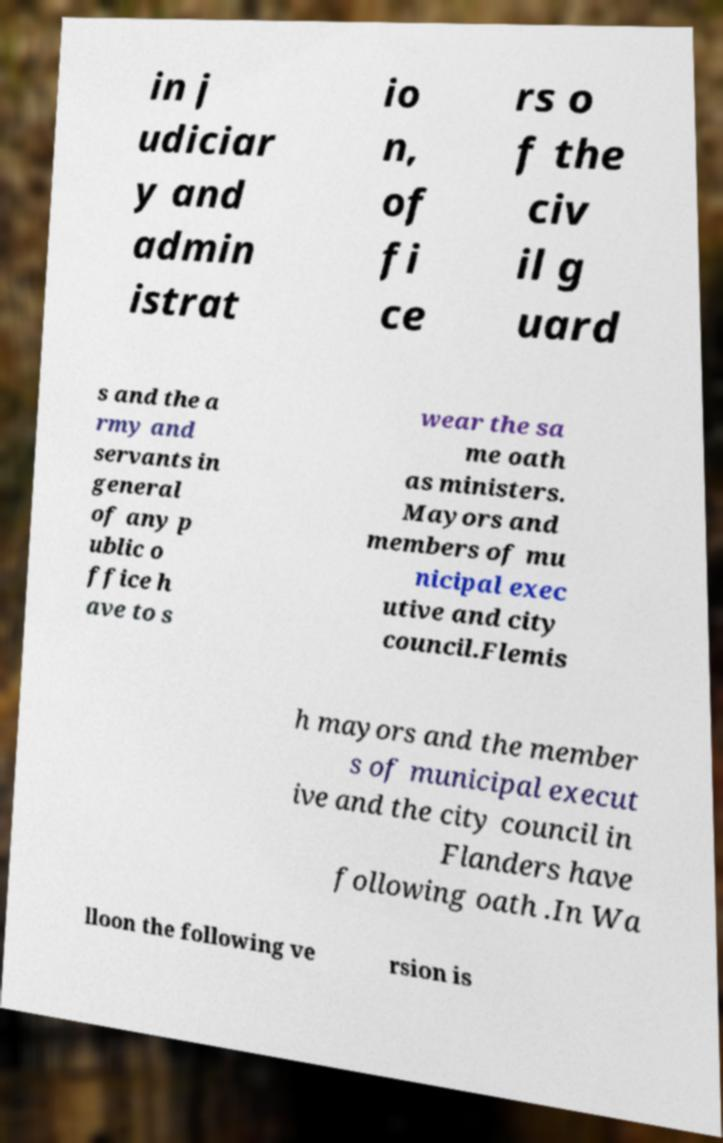There's text embedded in this image that I need extracted. Can you transcribe it verbatim? in j udiciar y and admin istrat io n, of fi ce rs o f the civ il g uard s and the a rmy and servants in general of any p ublic o ffice h ave to s wear the sa me oath as ministers. Mayors and members of mu nicipal exec utive and city council.Flemis h mayors and the member s of municipal execut ive and the city council in Flanders have following oath .In Wa lloon the following ve rsion is 